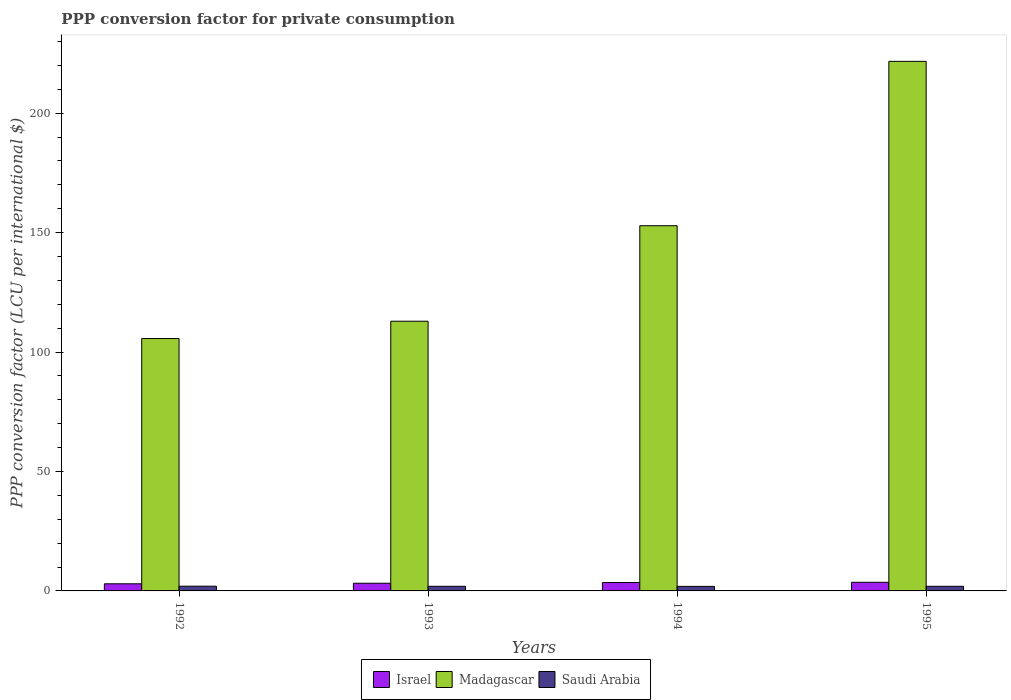How many different coloured bars are there?
Provide a short and direct response. 3. How many groups of bars are there?
Make the answer very short. 4. Are the number of bars on each tick of the X-axis equal?
Offer a terse response. Yes. How many bars are there on the 4th tick from the right?
Offer a very short reply. 3. What is the label of the 2nd group of bars from the left?
Give a very brief answer. 1993. In how many cases, is the number of bars for a given year not equal to the number of legend labels?
Provide a succinct answer. 0. What is the PPP conversion factor for private consumption in Saudi Arabia in 1995?
Ensure brevity in your answer.  1.94. Across all years, what is the maximum PPP conversion factor for private consumption in Israel?
Your answer should be compact. 3.61. Across all years, what is the minimum PPP conversion factor for private consumption in Israel?
Keep it short and to the point. 2.98. What is the total PPP conversion factor for private consumption in Israel in the graph?
Provide a short and direct response. 13.32. What is the difference between the PPP conversion factor for private consumption in Madagascar in 1993 and that in 1994?
Your answer should be compact. -39.97. What is the difference between the PPP conversion factor for private consumption in Saudi Arabia in 1992 and the PPP conversion factor for private consumption in Madagascar in 1994?
Your answer should be compact. -150.88. What is the average PPP conversion factor for private consumption in Madagascar per year?
Give a very brief answer. 148.26. In the year 1995, what is the difference between the PPP conversion factor for private consumption in Madagascar and PPP conversion factor for private consumption in Saudi Arabia?
Offer a very short reply. 219.72. In how many years, is the PPP conversion factor for private consumption in Israel greater than 120 LCU?
Provide a short and direct response. 0. What is the ratio of the PPP conversion factor for private consumption in Saudi Arabia in 1993 to that in 1994?
Make the answer very short. 1.02. Is the PPP conversion factor for private consumption in Madagascar in 1992 less than that in 1995?
Keep it short and to the point. Yes. Is the difference between the PPP conversion factor for private consumption in Madagascar in 1993 and 1994 greater than the difference between the PPP conversion factor for private consumption in Saudi Arabia in 1993 and 1994?
Offer a very short reply. No. What is the difference between the highest and the second highest PPP conversion factor for private consumption in Israel?
Your answer should be very brief. 0.1. What is the difference between the highest and the lowest PPP conversion factor for private consumption in Madagascar?
Your response must be concise. 116.02. In how many years, is the PPP conversion factor for private consumption in Saudi Arabia greater than the average PPP conversion factor for private consumption in Saudi Arabia taken over all years?
Offer a very short reply. 3. What does the 3rd bar from the left in 1994 represents?
Offer a very short reply. Saudi Arabia. What does the 1st bar from the right in 1992 represents?
Your answer should be very brief. Saudi Arabia. How many bars are there?
Your answer should be very brief. 12. Are all the bars in the graph horizontal?
Keep it short and to the point. No. How many years are there in the graph?
Your answer should be compact. 4. Are the values on the major ticks of Y-axis written in scientific E-notation?
Make the answer very short. No. Does the graph contain any zero values?
Keep it short and to the point. No. Does the graph contain grids?
Offer a very short reply. No. How many legend labels are there?
Your response must be concise. 3. How are the legend labels stacked?
Your answer should be very brief. Horizontal. What is the title of the graph?
Your answer should be compact. PPP conversion factor for private consumption. What is the label or title of the X-axis?
Offer a very short reply. Years. What is the label or title of the Y-axis?
Offer a terse response. PPP conversion factor (LCU per international $). What is the PPP conversion factor (LCU per international $) in Israel in 1992?
Provide a short and direct response. 2.98. What is the PPP conversion factor (LCU per international $) in Madagascar in 1992?
Your answer should be compact. 105.64. What is the PPP conversion factor (LCU per international $) of Saudi Arabia in 1992?
Keep it short and to the point. 1.98. What is the PPP conversion factor (LCU per international $) of Israel in 1993?
Give a very brief answer. 3.22. What is the PPP conversion factor (LCU per international $) in Madagascar in 1993?
Give a very brief answer. 112.89. What is the PPP conversion factor (LCU per international $) of Saudi Arabia in 1993?
Offer a very short reply. 1.94. What is the PPP conversion factor (LCU per international $) in Israel in 1994?
Give a very brief answer. 3.51. What is the PPP conversion factor (LCU per international $) of Madagascar in 1994?
Provide a succinct answer. 152.86. What is the PPP conversion factor (LCU per international $) of Saudi Arabia in 1994?
Keep it short and to the point. 1.9. What is the PPP conversion factor (LCU per international $) in Israel in 1995?
Make the answer very short. 3.61. What is the PPP conversion factor (LCU per international $) in Madagascar in 1995?
Your response must be concise. 221.66. What is the PPP conversion factor (LCU per international $) of Saudi Arabia in 1995?
Provide a short and direct response. 1.94. Across all years, what is the maximum PPP conversion factor (LCU per international $) in Israel?
Your answer should be compact. 3.61. Across all years, what is the maximum PPP conversion factor (LCU per international $) of Madagascar?
Offer a very short reply. 221.66. Across all years, what is the maximum PPP conversion factor (LCU per international $) of Saudi Arabia?
Your answer should be very brief. 1.98. Across all years, what is the minimum PPP conversion factor (LCU per international $) in Israel?
Make the answer very short. 2.98. Across all years, what is the minimum PPP conversion factor (LCU per international $) in Madagascar?
Your answer should be compact. 105.64. Across all years, what is the minimum PPP conversion factor (LCU per international $) in Saudi Arabia?
Your response must be concise. 1.9. What is the total PPP conversion factor (LCU per international $) in Israel in the graph?
Make the answer very short. 13.32. What is the total PPP conversion factor (LCU per international $) of Madagascar in the graph?
Provide a succinct answer. 593.05. What is the total PPP conversion factor (LCU per international $) of Saudi Arabia in the graph?
Make the answer very short. 7.76. What is the difference between the PPP conversion factor (LCU per international $) in Israel in 1992 and that in 1993?
Offer a terse response. -0.24. What is the difference between the PPP conversion factor (LCU per international $) of Madagascar in 1992 and that in 1993?
Your response must be concise. -7.24. What is the difference between the PPP conversion factor (LCU per international $) of Saudi Arabia in 1992 and that in 1993?
Provide a short and direct response. 0.04. What is the difference between the PPP conversion factor (LCU per international $) in Israel in 1992 and that in 1994?
Give a very brief answer. -0.53. What is the difference between the PPP conversion factor (LCU per international $) in Madagascar in 1992 and that in 1994?
Provide a succinct answer. -47.22. What is the difference between the PPP conversion factor (LCU per international $) of Saudi Arabia in 1992 and that in 1994?
Provide a short and direct response. 0.07. What is the difference between the PPP conversion factor (LCU per international $) in Israel in 1992 and that in 1995?
Keep it short and to the point. -0.63. What is the difference between the PPP conversion factor (LCU per international $) of Madagascar in 1992 and that in 1995?
Offer a terse response. -116.02. What is the difference between the PPP conversion factor (LCU per international $) in Saudi Arabia in 1992 and that in 1995?
Provide a succinct answer. 0.04. What is the difference between the PPP conversion factor (LCU per international $) of Israel in 1993 and that in 1994?
Ensure brevity in your answer.  -0.29. What is the difference between the PPP conversion factor (LCU per international $) in Madagascar in 1993 and that in 1994?
Provide a short and direct response. -39.97. What is the difference between the PPP conversion factor (LCU per international $) of Saudi Arabia in 1993 and that in 1994?
Your answer should be very brief. 0.04. What is the difference between the PPP conversion factor (LCU per international $) of Israel in 1993 and that in 1995?
Give a very brief answer. -0.39. What is the difference between the PPP conversion factor (LCU per international $) of Madagascar in 1993 and that in 1995?
Give a very brief answer. -108.78. What is the difference between the PPP conversion factor (LCU per international $) in Saudi Arabia in 1993 and that in 1995?
Offer a very short reply. 0. What is the difference between the PPP conversion factor (LCU per international $) of Israel in 1994 and that in 1995?
Your answer should be very brief. -0.1. What is the difference between the PPP conversion factor (LCU per international $) of Madagascar in 1994 and that in 1995?
Provide a succinct answer. -68.8. What is the difference between the PPP conversion factor (LCU per international $) of Saudi Arabia in 1994 and that in 1995?
Offer a terse response. -0.04. What is the difference between the PPP conversion factor (LCU per international $) in Israel in 1992 and the PPP conversion factor (LCU per international $) in Madagascar in 1993?
Your response must be concise. -109.9. What is the difference between the PPP conversion factor (LCU per international $) of Madagascar in 1992 and the PPP conversion factor (LCU per international $) of Saudi Arabia in 1993?
Ensure brevity in your answer.  103.7. What is the difference between the PPP conversion factor (LCU per international $) in Israel in 1992 and the PPP conversion factor (LCU per international $) in Madagascar in 1994?
Keep it short and to the point. -149.88. What is the difference between the PPP conversion factor (LCU per international $) in Israel in 1992 and the PPP conversion factor (LCU per international $) in Saudi Arabia in 1994?
Give a very brief answer. 1.08. What is the difference between the PPP conversion factor (LCU per international $) in Madagascar in 1992 and the PPP conversion factor (LCU per international $) in Saudi Arabia in 1994?
Keep it short and to the point. 103.74. What is the difference between the PPP conversion factor (LCU per international $) in Israel in 1992 and the PPP conversion factor (LCU per international $) in Madagascar in 1995?
Offer a very short reply. -218.68. What is the difference between the PPP conversion factor (LCU per international $) in Israel in 1992 and the PPP conversion factor (LCU per international $) in Saudi Arabia in 1995?
Your response must be concise. 1.04. What is the difference between the PPP conversion factor (LCU per international $) in Madagascar in 1992 and the PPP conversion factor (LCU per international $) in Saudi Arabia in 1995?
Give a very brief answer. 103.7. What is the difference between the PPP conversion factor (LCU per international $) of Israel in 1993 and the PPP conversion factor (LCU per international $) of Madagascar in 1994?
Offer a very short reply. -149.64. What is the difference between the PPP conversion factor (LCU per international $) of Israel in 1993 and the PPP conversion factor (LCU per international $) of Saudi Arabia in 1994?
Provide a short and direct response. 1.32. What is the difference between the PPP conversion factor (LCU per international $) in Madagascar in 1993 and the PPP conversion factor (LCU per international $) in Saudi Arabia in 1994?
Offer a very short reply. 110.98. What is the difference between the PPP conversion factor (LCU per international $) in Israel in 1993 and the PPP conversion factor (LCU per international $) in Madagascar in 1995?
Your response must be concise. -218.45. What is the difference between the PPP conversion factor (LCU per international $) in Israel in 1993 and the PPP conversion factor (LCU per international $) in Saudi Arabia in 1995?
Your response must be concise. 1.28. What is the difference between the PPP conversion factor (LCU per international $) in Madagascar in 1993 and the PPP conversion factor (LCU per international $) in Saudi Arabia in 1995?
Offer a very short reply. 110.95. What is the difference between the PPP conversion factor (LCU per international $) of Israel in 1994 and the PPP conversion factor (LCU per international $) of Madagascar in 1995?
Provide a short and direct response. -218.15. What is the difference between the PPP conversion factor (LCU per international $) of Israel in 1994 and the PPP conversion factor (LCU per international $) of Saudi Arabia in 1995?
Your answer should be compact. 1.57. What is the difference between the PPP conversion factor (LCU per international $) of Madagascar in 1994 and the PPP conversion factor (LCU per international $) of Saudi Arabia in 1995?
Provide a short and direct response. 150.92. What is the average PPP conversion factor (LCU per international $) in Israel per year?
Offer a terse response. 3.33. What is the average PPP conversion factor (LCU per international $) in Madagascar per year?
Provide a succinct answer. 148.26. What is the average PPP conversion factor (LCU per international $) of Saudi Arabia per year?
Your answer should be compact. 1.94. In the year 1992, what is the difference between the PPP conversion factor (LCU per international $) in Israel and PPP conversion factor (LCU per international $) in Madagascar?
Your answer should be very brief. -102.66. In the year 1992, what is the difference between the PPP conversion factor (LCU per international $) in Israel and PPP conversion factor (LCU per international $) in Saudi Arabia?
Your response must be concise. 1. In the year 1992, what is the difference between the PPP conversion factor (LCU per international $) of Madagascar and PPP conversion factor (LCU per international $) of Saudi Arabia?
Your response must be concise. 103.67. In the year 1993, what is the difference between the PPP conversion factor (LCU per international $) in Israel and PPP conversion factor (LCU per international $) in Madagascar?
Your answer should be compact. -109.67. In the year 1993, what is the difference between the PPP conversion factor (LCU per international $) in Israel and PPP conversion factor (LCU per international $) in Saudi Arabia?
Make the answer very short. 1.28. In the year 1993, what is the difference between the PPP conversion factor (LCU per international $) in Madagascar and PPP conversion factor (LCU per international $) in Saudi Arabia?
Give a very brief answer. 110.94. In the year 1994, what is the difference between the PPP conversion factor (LCU per international $) in Israel and PPP conversion factor (LCU per international $) in Madagascar?
Give a very brief answer. -149.35. In the year 1994, what is the difference between the PPP conversion factor (LCU per international $) in Israel and PPP conversion factor (LCU per international $) in Saudi Arabia?
Offer a very short reply. 1.61. In the year 1994, what is the difference between the PPP conversion factor (LCU per international $) of Madagascar and PPP conversion factor (LCU per international $) of Saudi Arabia?
Provide a short and direct response. 150.96. In the year 1995, what is the difference between the PPP conversion factor (LCU per international $) in Israel and PPP conversion factor (LCU per international $) in Madagascar?
Provide a succinct answer. -218.05. In the year 1995, what is the difference between the PPP conversion factor (LCU per international $) in Israel and PPP conversion factor (LCU per international $) in Saudi Arabia?
Your answer should be very brief. 1.67. In the year 1995, what is the difference between the PPP conversion factor (LCU per international $) of Madagascar and PPP conversion factor (LCU per international $) of Saudi Arabia?
Make the answer very short. 219.72. What is the ratio of the PPP conversion factor (LCU per international $) in Israel in 1992 to that in 1993?
Provide a short and direct response. 0.93. What is the ratio of the PPP conversion factor (LCU per international $) in Madagascar in 1992 to that in 1993?
Your answer should be compact. 0.94. What is the ratio of the PPP conversion factor (LCU per international $) of Saudi Arabia in 1992 to that in 1993?
Make the answer very short. 1.02. What is the ratio of the PPP conversion factor (LCU per international $) of Israel in 1992 to that in 1994?
Your answer should be compact. 0.85. What is the ratio of the PPP conversion factor (LCU per international $) of Madagascar in 1992 to that in 1994?
Make the answer very short. 0.69. What is the ratio of the PPP conversion factor (LCU per international $) of Saudi Arabia in 1992 to that in 1994?
Offer a very short reply. 1.04. What is the ratio of the PPP conversion factor (LCU per international $) of Israel in 1992 to that in 1995?
Offer a terse response. 0.83. What is the ratio of the PPP conversion factor (LCU per international $) of Madagascar in 1992 to that in 1995?
Provide a short and direct response. 0.48. What is the ratio of the PPP conversion factor (LCU per international $) of Israel in 1993 to that in 1994?
Your answer should be compact. 0.92. What is the ratio of the PPP conversion factor (LCU per international $) of Madagascar in 1993 to that in 1994?
Your answer should be very brief. 0.74. What is the ratio of the PPP conversion factor (LCU per international $) of Saudi Arabia in 1993 to that in 1994?
Ensure brevity in your answer.  1.02. What is the ratio of the PPP conversion factor (LCU per international $) in Israel in 1993 to that in 1995?
Ensure brevity in your answer.  0.89. What is the ratio of the PPP conversion factor (LCU per international $) in Madagascar in 1993 to that in 1995?
Your response must be concise. 0.51. What is the ratio of the PPP conversion factor (LCU per international $) of Israel in 1994 to that in 1995?
Make the answer very short. 0.97. What is the ratio of the PPP conversion factor (LCU per international $) of Madagascar in 1994 to that in 1995?
Your answer should be compact. 0.69. What is the ratio of the PPP conversion factor (LCU per international $) of Saudi Arabia in 1994 to that in 1995?
Ensure brevity in your answer.  0.98. What is the difference between the highest and the second highest PPP conversion factor (LCU per international $) in Israel?
Your answer should be very brief. 0.1. What is the difference between the highest and the second highest PPP conversion factor (LCU per international $) of Madagascar?
Ensure brevity in your answer.  68.8. What is the difference between the highest and the second highest PPP conversion factor (LCU per international $) in Saudi Arabia?
Keep it short and to the point. 0.04. What is the difference between the highest and the lowest PPP conversion factor (LCU per international $) in Israel?
Your answer should be compact. 0.63. What is the difference between the highest and the lowest PPP conversion factor (LCU per international $) of Madagascar?
Offer a terse response. 116.02. What is the difference between the highest and the lowest PPP conversion factor (LCU per international $) in Saudi Arabia?
Your answer should be compact. 0.07. 